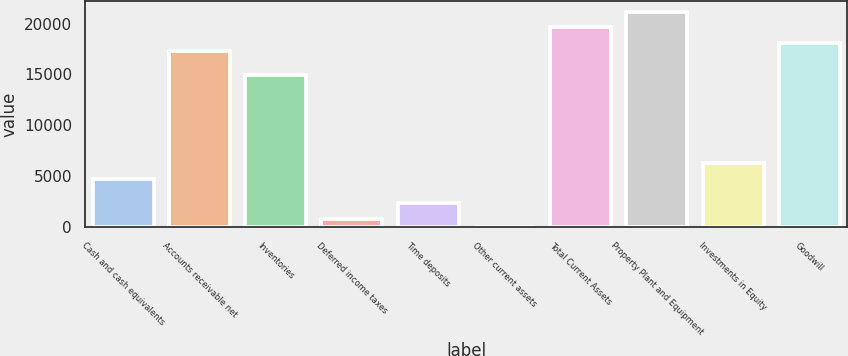Convert chart. <chart><loc_0><loc_0><loc_500><loc_500><bar_chart><fcel>Cash and cash equivalents<fcel>Accounts receivable net<fcel>Inventories<fcel>Deferred income taxes<fcel>Time deposits<fcel>Other current assets<fcel>Total Current Assets<fcel>Property Plant and Equipment<fcel>Investments in Equity<fcel>Goodwill<nl><fcel>4770.96<fcel>17269.5<fcel>14926<fcel>865.16<fcel>2427.48<fcel>84<fcel>19613<fcel>21175.3<fcel>6333.28<fcel>18050.7<nl></chart> 